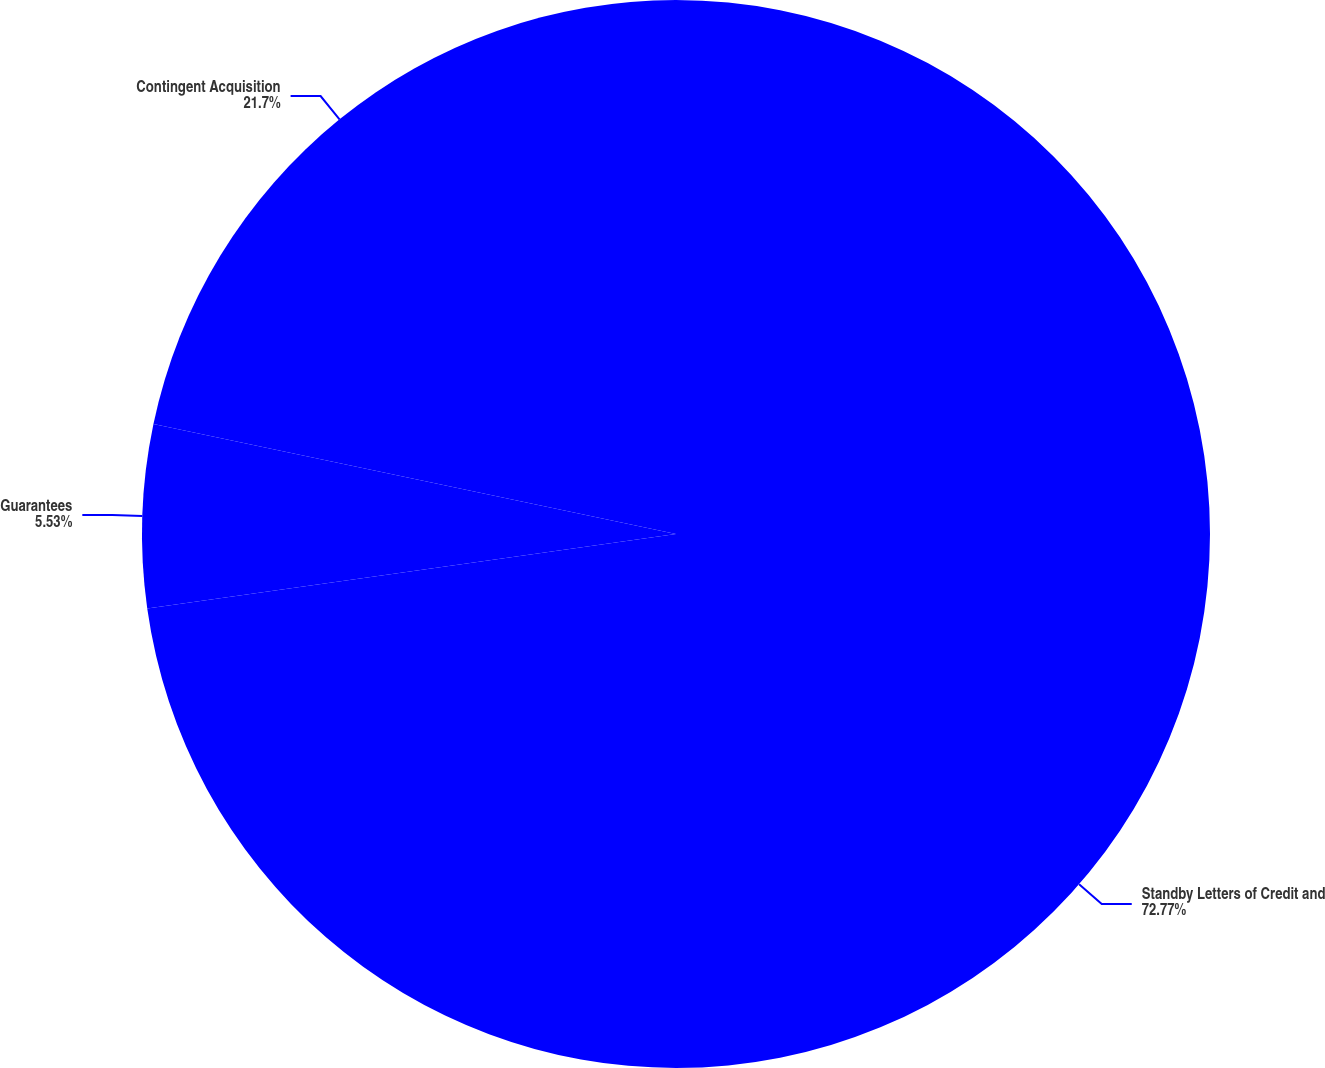<chart> <loc_0><loc_0><loc_500><loc_500><pie_chart><fcel>Standby Letters of Credit and<fcel>Guarantees<fcel>Contingent Acquisition<nl><fcel>72.77%<fcel>5.53%<fcel>21.7%<nl></chart> 